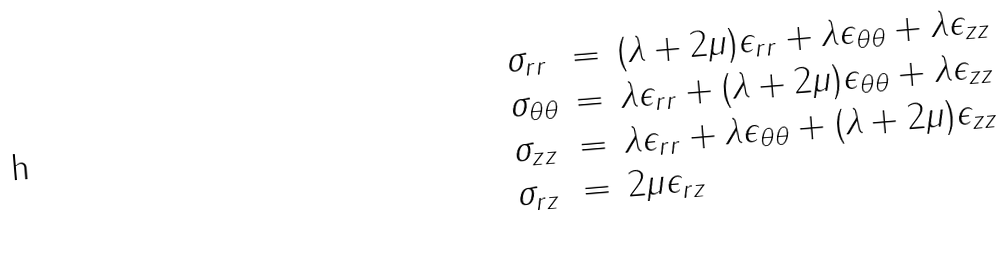Convert formula to latex. <formula><loc_0><loc_0><loc_500><loc_500>\begin{array} { l l l } \sigma _ { r r } & = & ( \lambda + 2 \mu ) \epsilon _ { r r } + \lambda \epsilon _ { \theta \theta } + \lambda \epsilon _ { z z } \\ \sigma _ { \theta \theta } & = & \lambda \epsilon _ { r r } + ( \lambda + 2 \mu ) \epsilon _ { \theta \theta } + \lambda \epsilon _ { z z } \\ \sigma _ { z z } & = & \lambda \epsilon _ { r r } + \lambda \epsilon _ { \theta \theta } + ( \lambda + 2 \mu ) \epsilon _ { z z } \\ \sigma _ { r z } & = & 2 \mu \epsilon _ { r z } \end{array}</formula> 